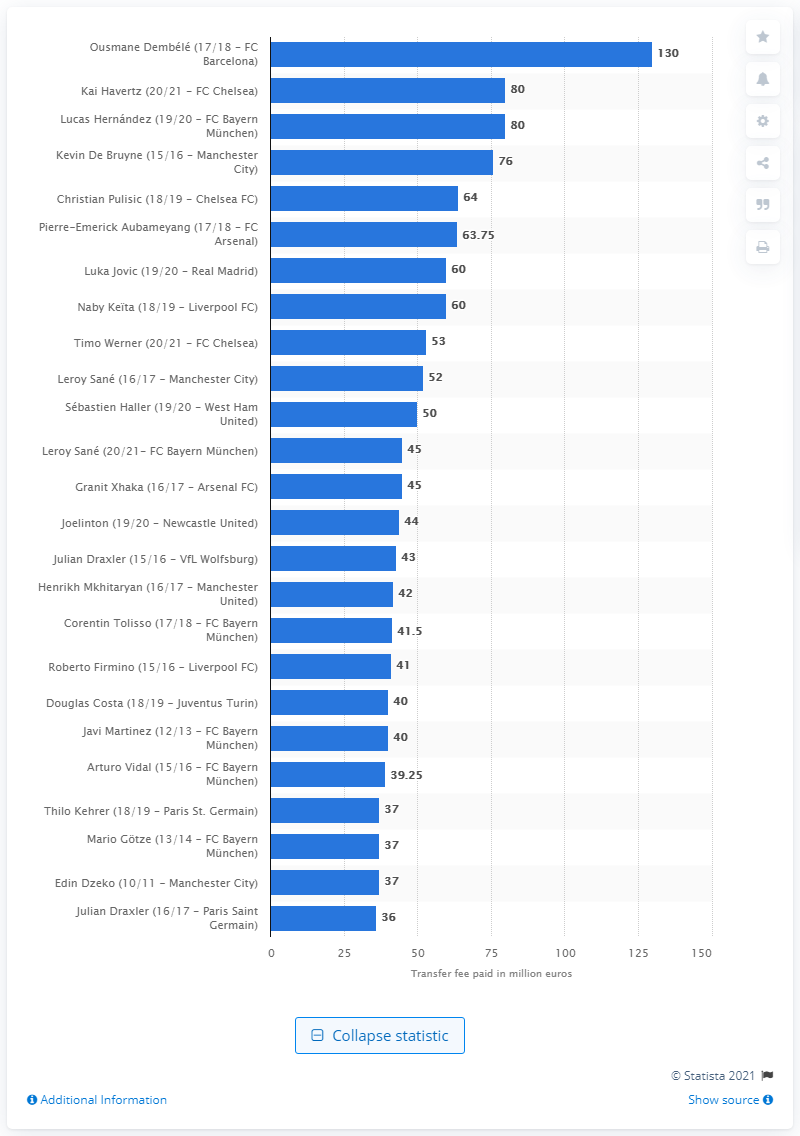Highlight a few significant elements in this photo. FC Bayern Munich paid a transfer fee of 40 for Javi Martinez during the 2014-2015 season. 